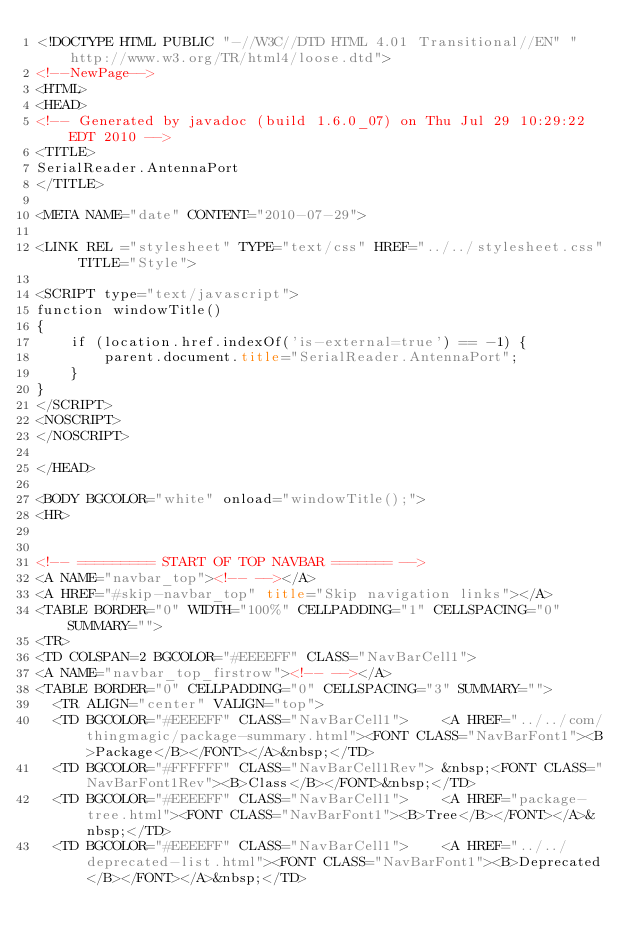Convert code to text. <code><loc_0><loc_0><loc_500><loc_500><_HTML_><!DOCTYPE HTML PUBLIC "-//W3C//DTD HTML 4.01 Transitional//EN" "http://www.w3.org/TR/html4/loose.dtd">
<!--NewPage-->
<HTML>
<HEAD>
<!-- Generated by javadoc (build 1.6.0_07) on Thu Jul 29 10:29:22 EDT 2010 -->
<TITLE>
SerialReader.AntennaPort
</TITLE>

<META NAME="date" CONTENT="2010-07-29">

<LINK REL ="stylesheet" TYPE="text/css" HREF="../../stylesheet.css" TITLE="Style">

<SCRIPT type="text/javascript">
function windowTitle()
{
    if (location.href.indexOf('is-external=true') == -1) {
        parent.document.title="SerialReader.AntennaPort";
    }
}
</SCRIPT>
<NOSCRIPT>
</NOSCRIPT>

</HEAD>

<BODY BGCOLOR="white" onload="windowTitle();">
<HR>


<!-- ========= START OF TOP NAVBAR ======= -->
<A NAME="navbar_top"><!-- --></A>
<A HREF="#skip-navbar_top" title="Skip navigation links"></A>
<TABLE BORDER="0" WIDTH="100%" CELLPADDING="1" CELLSPACING="0" SUMMARY="">
<TR>
<TD COLSPAN=2 BGCOLOR="#EEEEFF" CLASS="NavBarCell1">
<A NAME="navbar_top_firstrow"><!-- --></A>
<TABLE BORDER="0" CELLPADDING="0" CELLSPACING="3" SUMMARY="">
  <TR ALIGN="center" VALIGN="top">
  <TD BGCOLOR="#EEEEFF" CLASS="NavBarCell1">    <A HREF="../../com/thingmagic/package-summary.html"><FONT CLASS="NavBarFont1"><B>Package</B></FONT></A>&nbsp;</TD>
  <TD BGCOLOR="#FFFFFF" CLASS="NavBarCell1Rev"> &nbsp;<FONT CLASS="NavBarFont1Rev"><B>Class</B></FONT>&nbsp;</TD>
  <TD BGCOLOR="#EEEEFF" CLASS="NavBarCell1">    <A HREF="package-tree.html"><FONT CLASS="NavBarFont1"><B>Tree</B></FONT></A>&nbsp;</TD>
  <TD BGCOLOR="#EEEEFF" CLASS="NavBarCell1">    <A HREF="../../deprecated-list.html"><FONT CLASS="NavBarFont1"><B>Deprecated</B></FONT></A>&nbsp;</TD></code> 